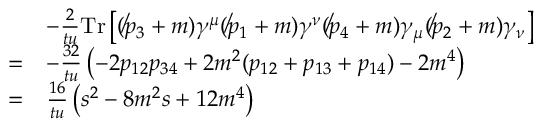Convert formula to latex. <formula><loc_0><loc_0><loc_500><loc_500>{ \begin{array} { r l } & { - { \frac { 2 } { t u } } T r \left [ ( \not p _ { 3 } + m ) \gamma ^ { \mu } ( \not p _ { 1 } + m ) \gamma ^ { \nu } ( \not p _ { 4 } + m ) \gamma _ { \mu } ( \not p _ { 2 } + m ) \gamma _ { \nu } \right ] } \\ { = } & { - { \frac { 3 2 } { t u } } \left ( - 2 p _ { 1 2 } p _ { 3 4 } + 2 m ^ { 2 } ( p _ { 1 2 } + p _ { 1 3 } + p _ { 1 4 } ) - 2 m ^ { 4 } \right ) } \\ { = } & { { \frac { 1 6 } { t u } } \left ( s ^ { 2 } - 8 m ^ { 2 } s + 1 2 m ^ { 4 } \right ) } \end{array} }</formula> 